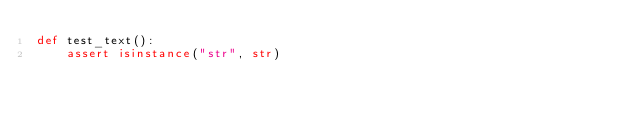Convert code to text. <code><loc_0><loc_0><loc_500><loc_500><_Python_>def test_text():
    assert isinstance("str", str)
</code> 